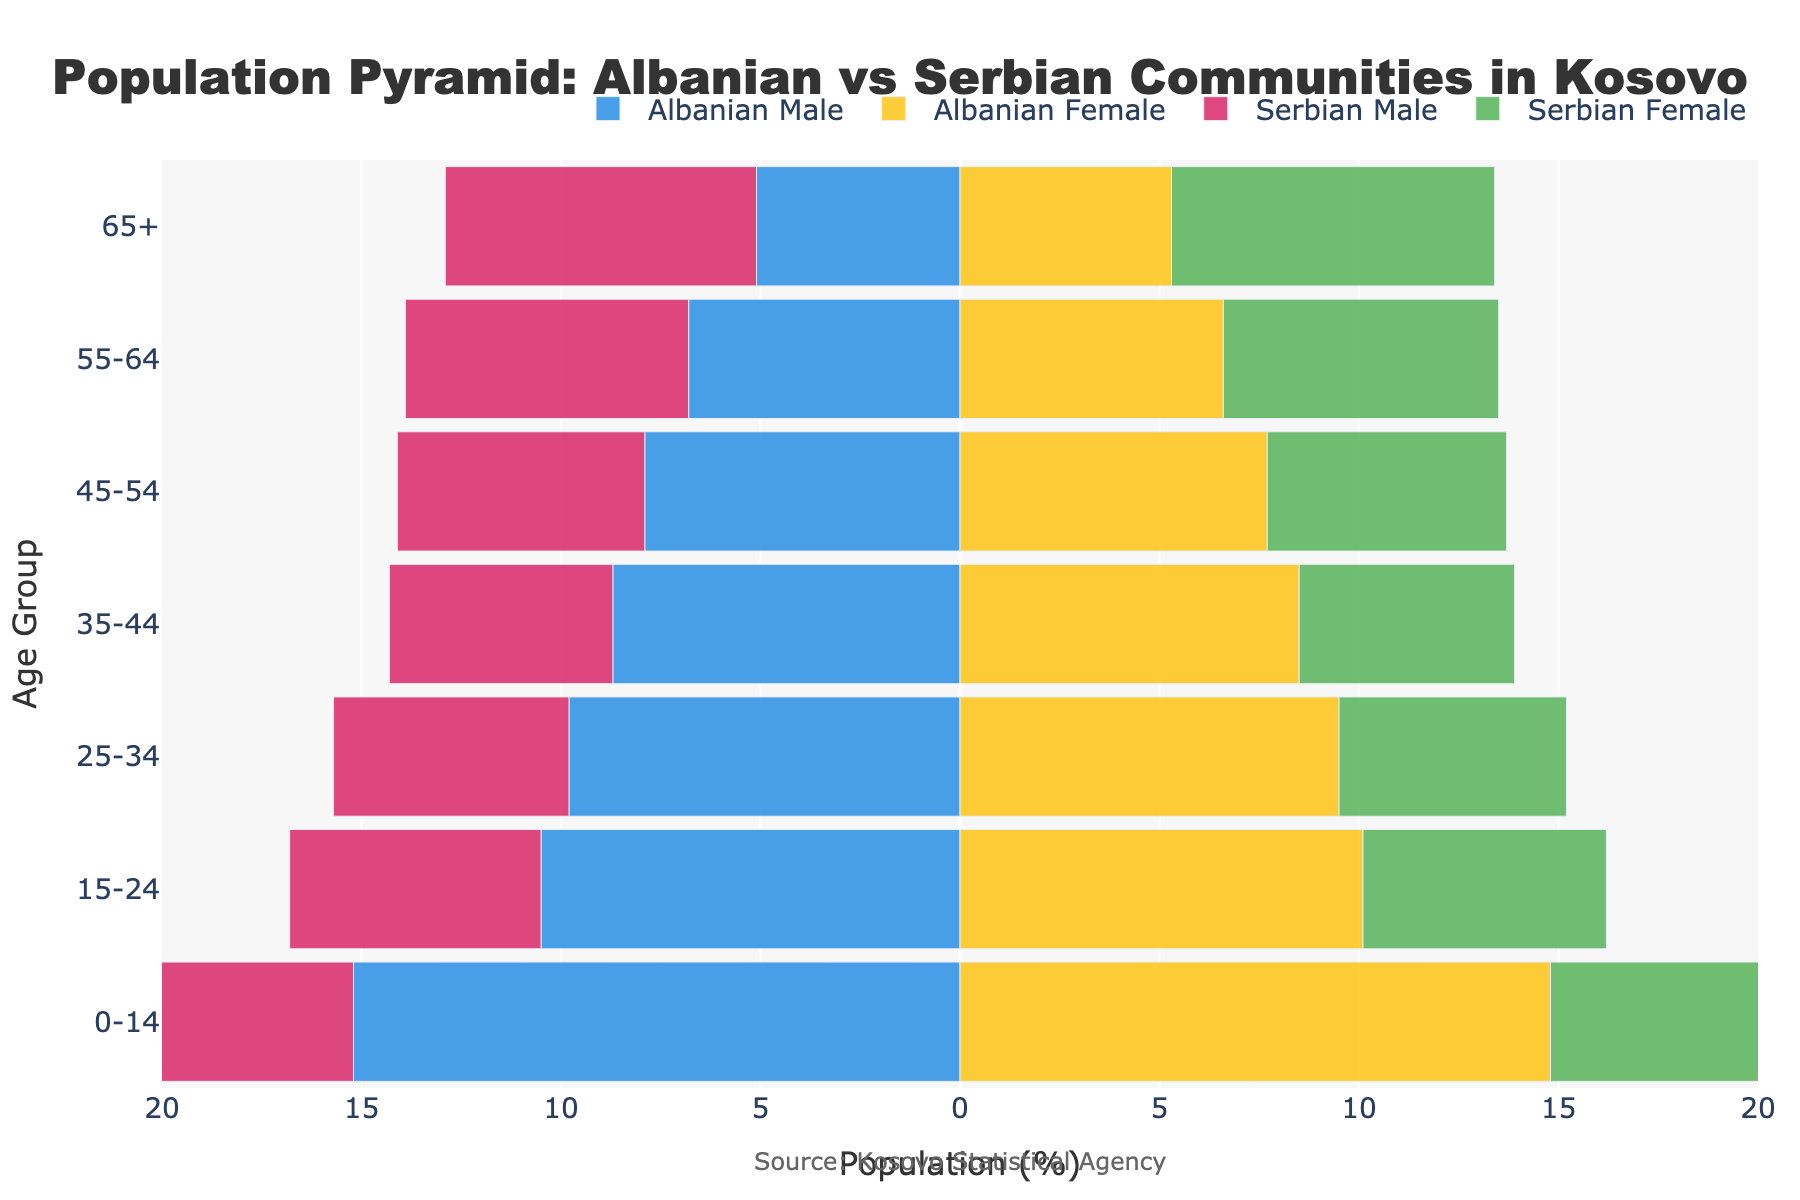Which community has a higher percentage of the population in the 0-14 age group? By examining the bars for the 0-14 age group, you compare the lengths of the Albanian Male and Albanian Female bars combined versus the Serbian Male and Serbian Female bars combined. The Albanian percentage (15.2% male + 14.8% female) exceeds the Serbian percentage (8.1% male + 7.9% female).
Answer: Albanian What is the gender balance like for the Serbian community in the 65+ age group? By comparing the lengths of the Serbian Male and Serbian Female bars for the 65+ age group, the Serbian Female bar is longer (8.1%) compared to the Serbian Male bar (7.8%), indicating a higher percentage of females in the older age group.
Answer: More females Compare the 55-64 age group for both communities. Which community has a higher percentage of the population in this age group? Summing the percentages for each gender in the 55-64 age group, we get Albanian: 6.8% male + 6.6% female = 13.4%, and Serbian: 7.1% male + 6.9% female = 14.0%. The Serbian community has a higher percentage.
Answer: Serbian What is the difference in the percentage of Albanian males and females in the 25-34 age group? Subtract the percentage of Albanian females from the percentage of Albanian males in the 25-34 age group: 9.8% - 9.5% = 0.3%.
Answer: 0.3% Is the male population of any age group greater in the Serbian community compared to the Albanian community? By scanning through each age group's male percentage bars, none of the Serbian Male bars are longer than the corresponding Albanian Male bars. Thus, the answer is no.
Answer: No What age group has the highest percentage of Serbian females? By checking the lengths of the Serbian Female bars across all age groups, the 65+ age group has the longest bar, which means it has the highest percentage.
Answer: 65+ What is the average percentage of the Albanian population in the age groups 15-24 and 25-34? First, sum the percentages for both age groups: (10.5% + 10.1%) / 2 for 15-24 and (9.8% + 9.5%) / 2 for 25-34, then average the two: (20.6 + 19.3) / 2 = 19.95%.
Answer: 19.95% Compare the 35-44 age group between both communities. Which gender and community combination has the smallest percentage? By examining the individual bars for the 35-44 age group, the smallest percentage is Serbian Female with 5.4%.
Answer: Serbian Female How does the population distribution change between the youngest (0-14) and oldest (65+) age groups within the Serbian community? The male percentage decreases from 8.1% to 7.8%, and the female percentage increases from 7.9% to 8.1%, showing a decrease in males and a slight increase in females from the youngest to the oldest age group.
Answer: Male decreases, Female increases In the Albanian community, which age group has the most balanced gender distribution? By finding the age group with the smallest difference between male and female percentages, the 25-34 age group has the closest values: 9.8% for males and 9.5% for females, giving a difference of 0.3%.
Answer: 25-34 